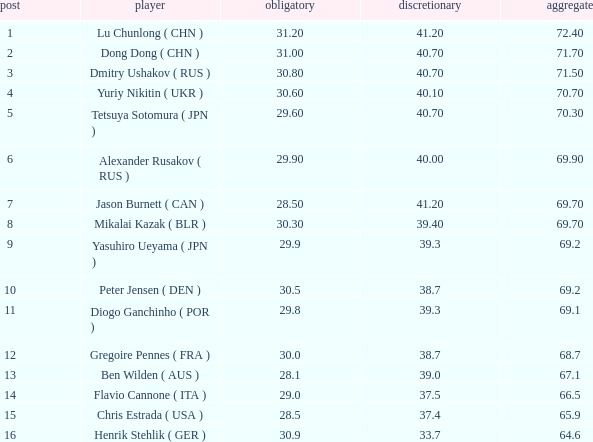What's the total compulsory when the total is more than 69.2 and the voluntary is 38.7? 0.0. 